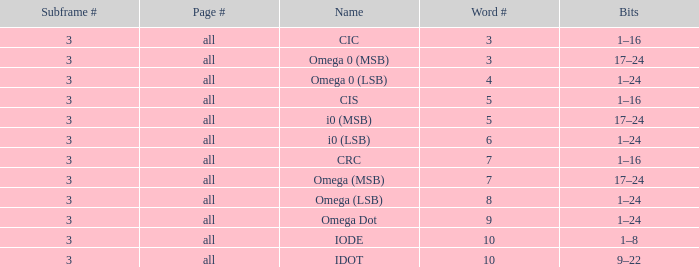For subframes with a count above 3, what is the cumulative word count? None. 